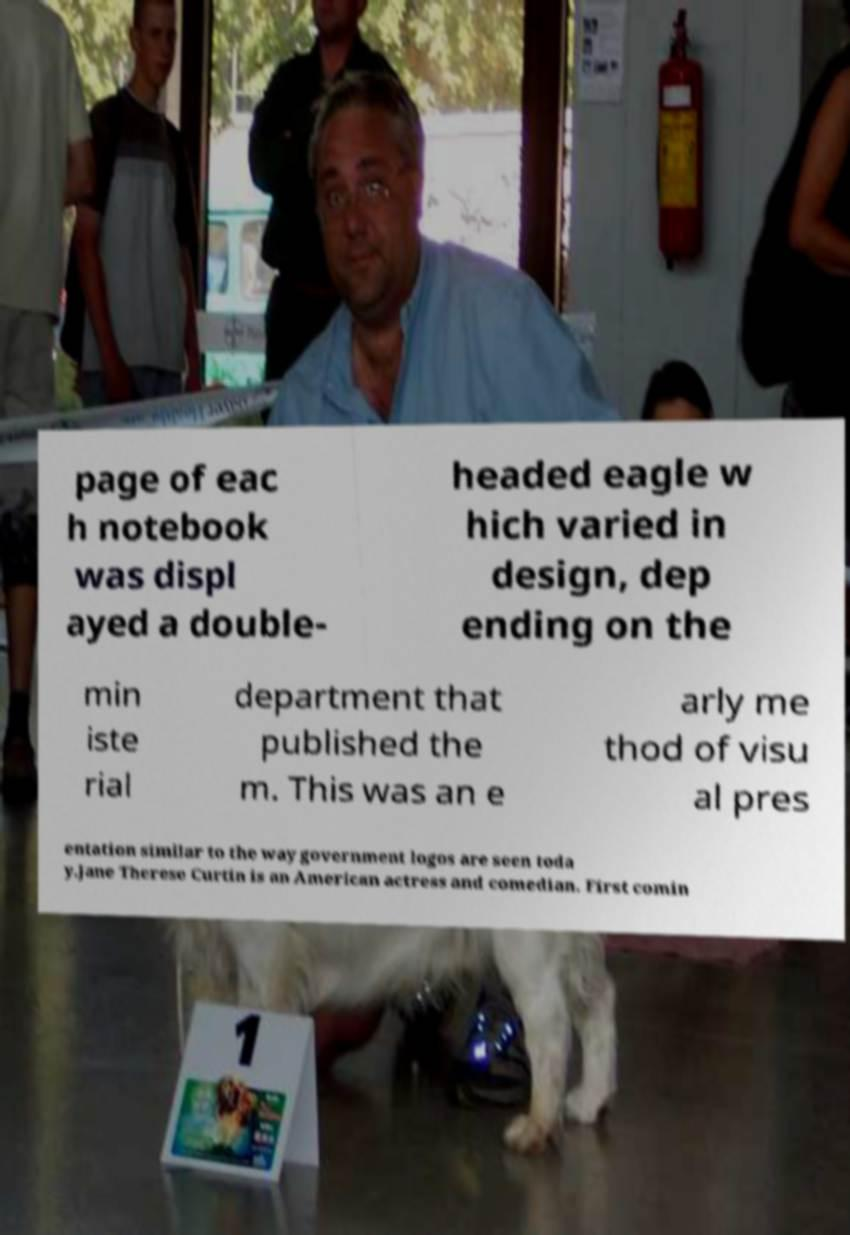For documentation purposes, I need the text within this image transcribed. Could you provide that? page of eac h notebook was displ ayed a double- headed eagle w hich varied in design, dep ending on the min iste rial department that published the m. This was an e arly me thod of visu al pres entation similar to the way government logos are seen toda y.Jane Therese Curtin is an American actress and comedian. First comin 